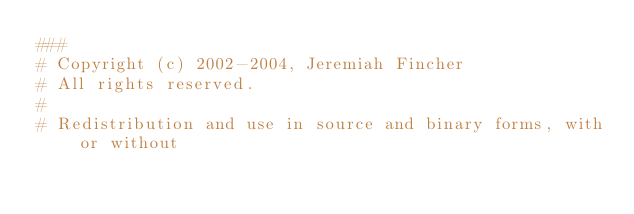<code> <loc_0><loc_0><loc_500><loc_500><_Python_>###
# Copyright (c) 2002-2004, Jeremiah Fincher
# All rights reserved.
#
# Redistribution and use in source and binary forms, with or without</code> 